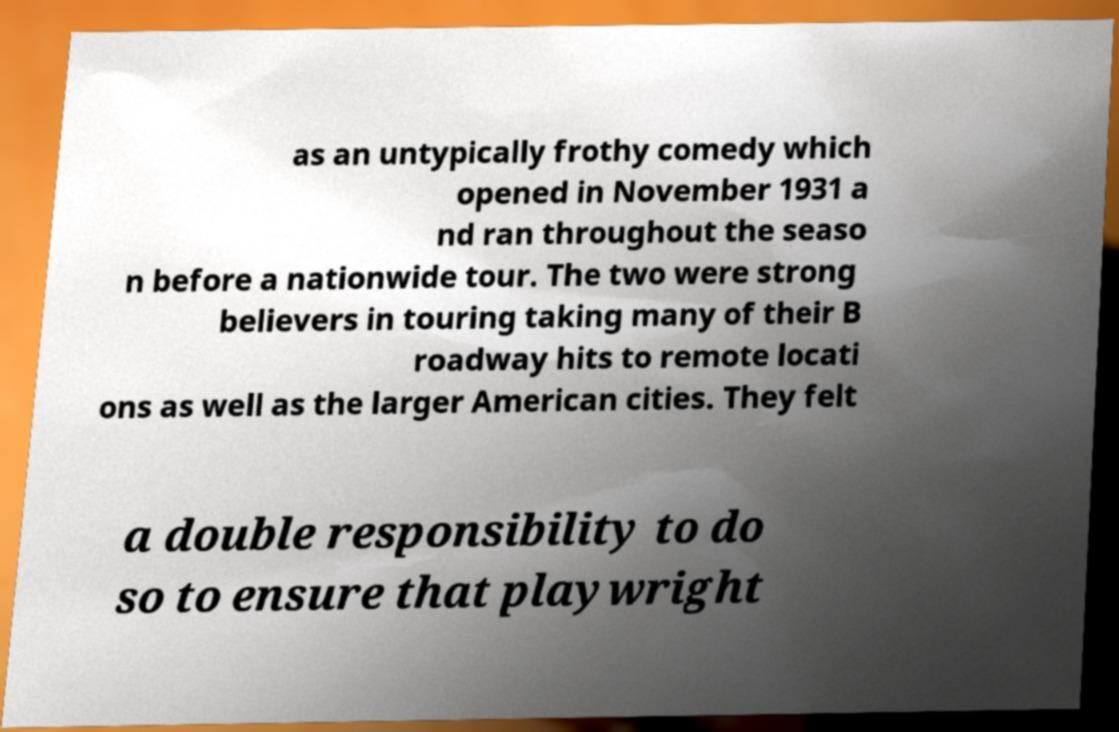Please read and relay the text visible in this image. What does it say? as an untypically frothy comedy which opened in November 1931 a nd ran throughout the seaso n before a nationwide tour. The two were strong believers in touring taking many of their B roadway hits to remote locati ons as well as the larger American cities. They felt a double responsibility to do so to ensure that playwright 